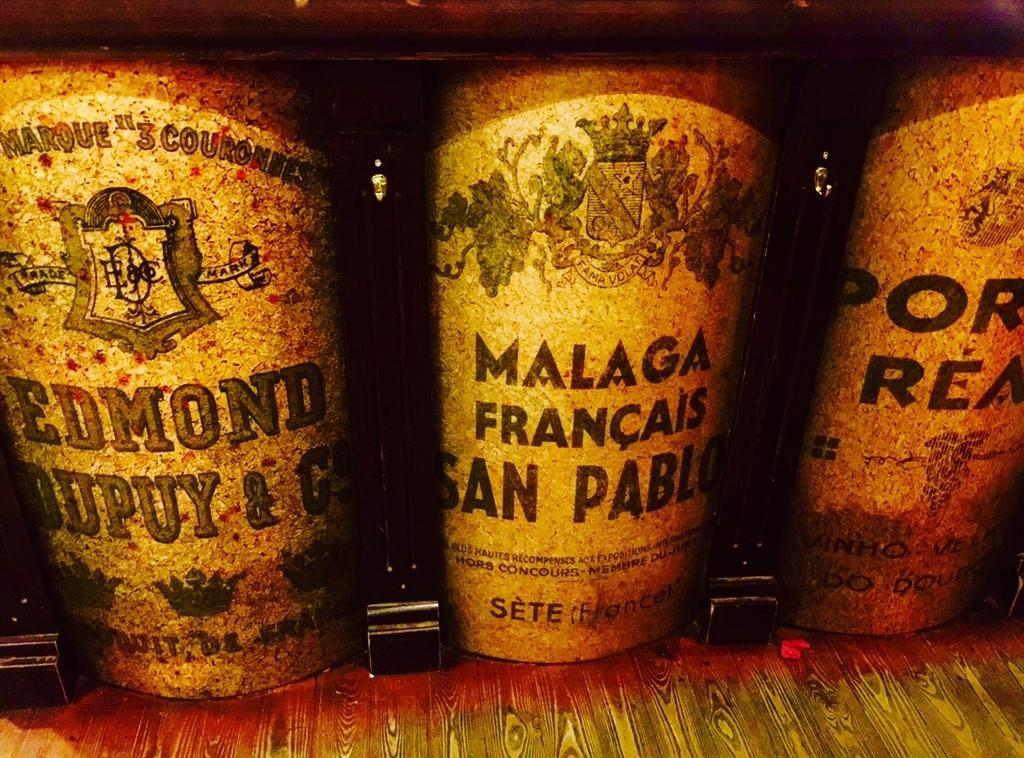Provide a one-sentence caption for the provided image. Three containers on a shelf with French labels on them. 